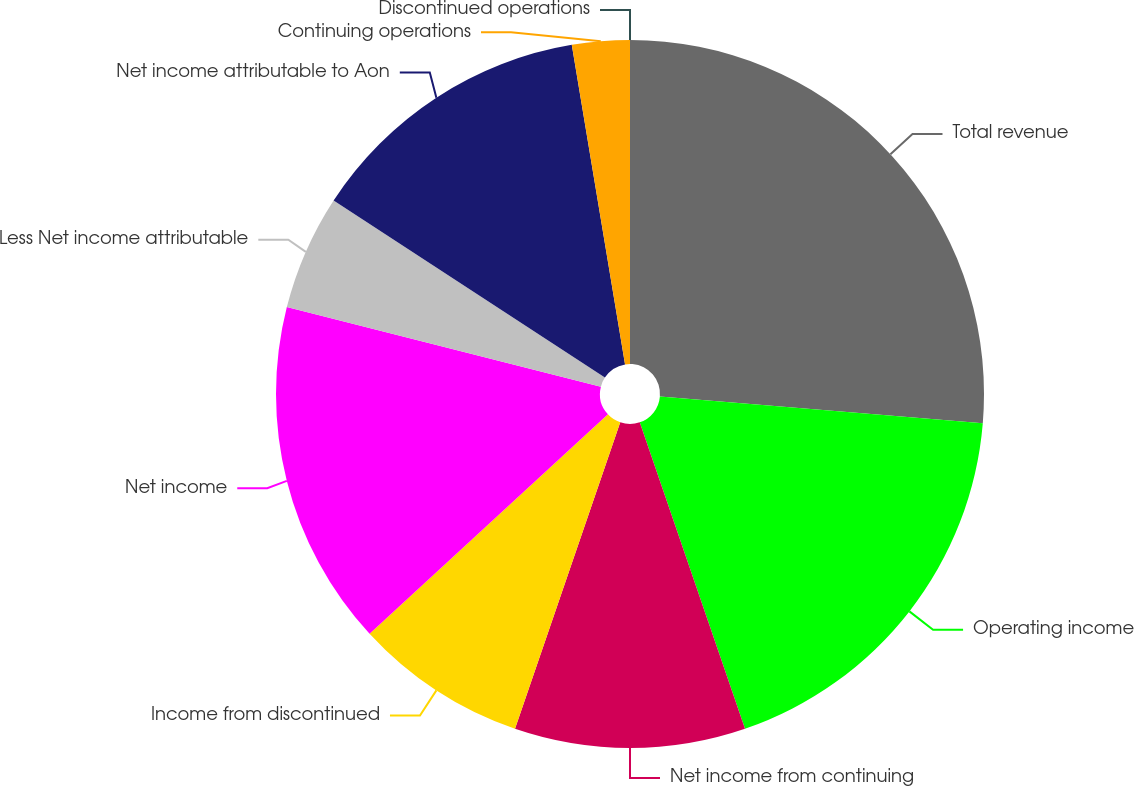Convert chart. <chart><loc_0><loc_0><loc_500><loc_500><pie_chart><fcel>Total revenue<fcel>Operating income<fcel>Net income from continuing<fcel>Income from discontinued<fcel>Net income<fcel>Less Net income attributable<fcel>Net income attributable to Aon<fcel>Continuing operations<fcel>Discontinued operations<nl><fcel>26.31%<fcel>18.42%<fcel>10.53%<fcel>7.89%<fcel>15.79%<fcel>5.26%<fcel>13.16%<fcel>2.63%<fcel>0.0%<nl></chart> 